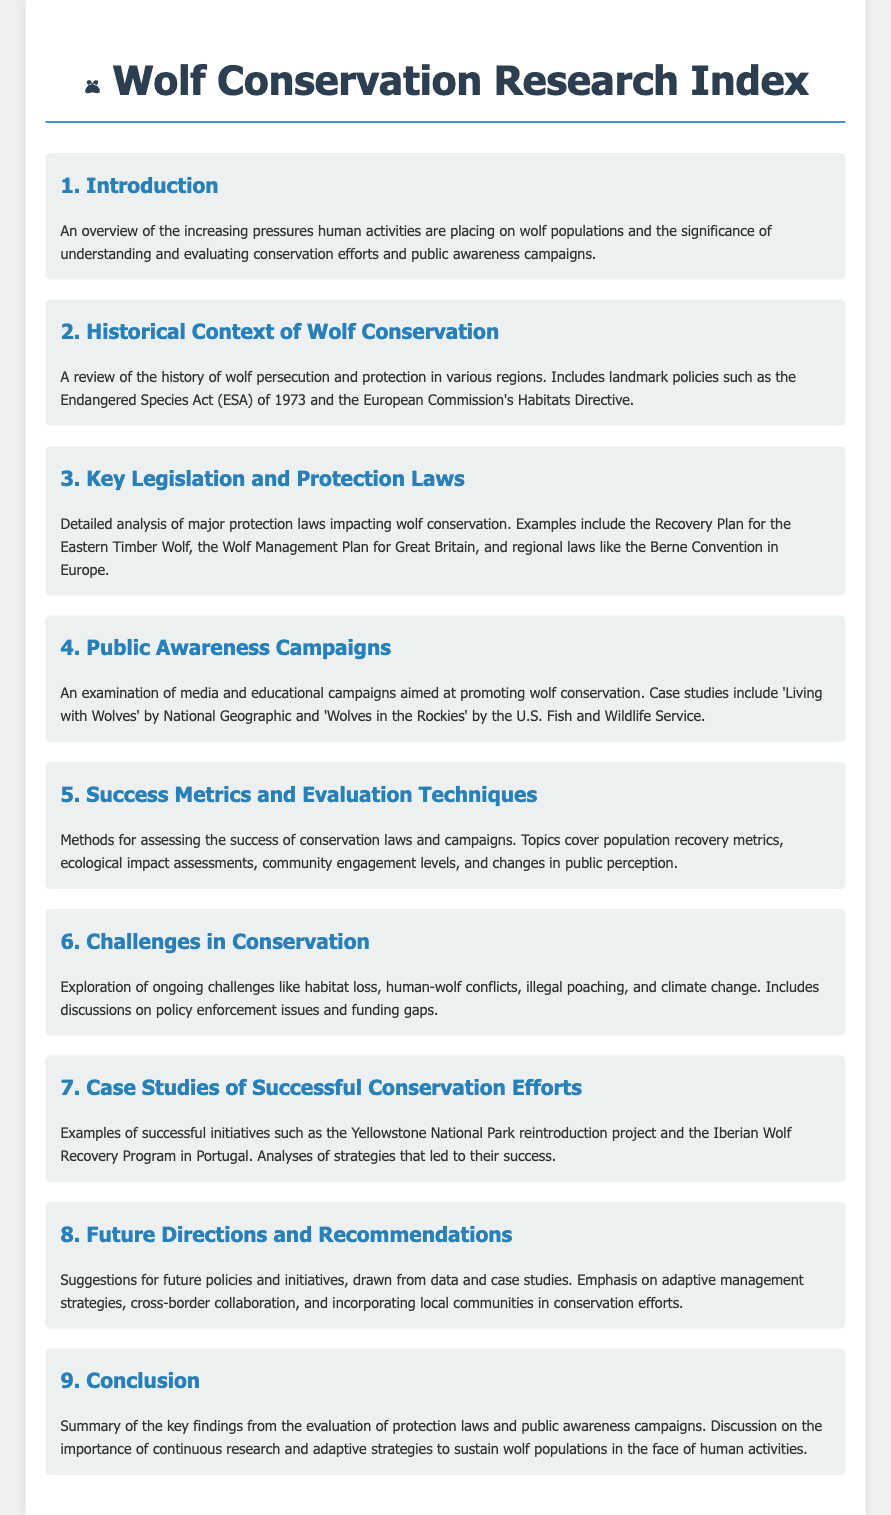what year was the Endangered Species Act enacted? The Endangered Species Act (ESA) was enacted in 1973, as mentioned in the historical context of the document.
Answer: 1973 what is the title of section 4? Section 4 focuses on Public Awareness Campaigns, discussing media and educational efforts to promote wolf conservation.
Answer: Public Awareness Campaigns how many case studies are mentioned in section 4? The document mentions two case studies in section 4, specifically 'Living with Wolves' and 'Wolves in the Rockies'.
Answer: 2 what are some challenges highlighted in section 6? Section 6 explores challenges such as habitat loss, human-wolf conflicts, illegal poaching, and climate change.
Answer: Habitat loss, human-wolf conflicts, illegal poaching, climate change what is one metric used for evaluating success in conservation efforts in section 5? Section 5 discusses various methods for assessing conservation success, including population recovery metrics.
Answer: Population recovery metrics what is the focus of section 8? Section 8 suggests future policies and initiatives related to wolf conservation, emphasizing various strategies.
Answer: Future directions and recommendations how many successful conservation efforts are highlighted in section 7? Section 7 provides examples of two successful initiatives: Yellowstone National Park reintroduction project and Iberian Wolf Recovery Program.
Answer: 2 what is a key theme in the conclusion of the document? The conclusion emphasizes the importance of continuous research and adaptive strategies to sustain wolf populations.
Answer: Continuous research and adaptive strategies 